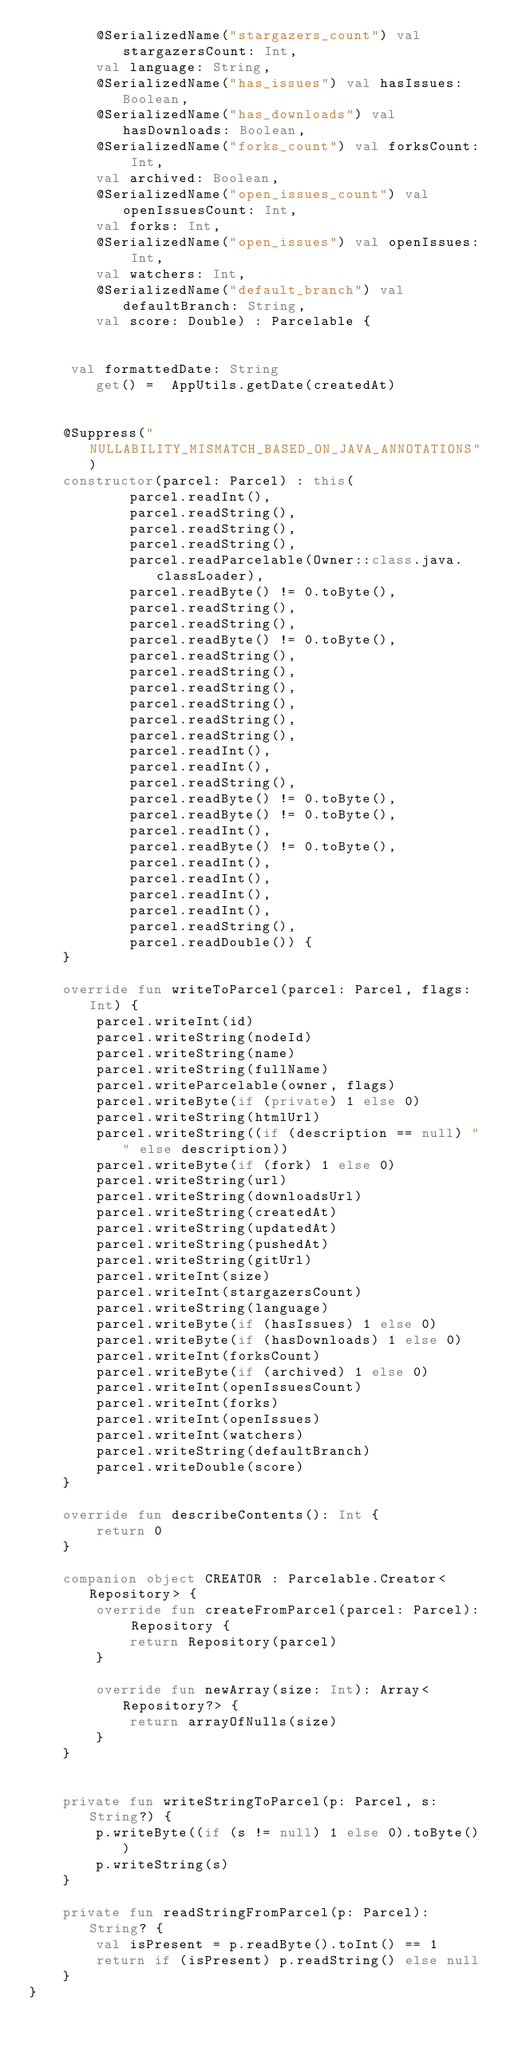<code> <loc_0><loc_0><loc_500><loc_500><_Kotlin_>        @SerializedName("stargazers_count") val stargazersCount: Int,
        val language: String,
        @SerializedName("has_issues") val hasIssues: Boolean,
        @SerializedName("has_downloads") val hasDownloads: Boolean,
        @SerializedName("forks_count") val forksCount: Int,
        val archived: Boolean,
        @SerializedName("open_issues_count") val openIssuesCount: Int,
        val forks: Int,
        @SerializedName("open_issues") val openIssues: Int,
        val watchers: Int,
        @SerializedName("default_branch") val defaultBranch: String,
        val score: Double) : Parcelable {


     val formattedDate: String
        get() =  AppUtils.getDate(createdAt)


    @Suppress("NULLABILITY_MISMATCH_BASED_ON_JAVA_ANNOTATIONS")
    constructor(parcel: Parcel) : this(
            parcel.readInt(),
            parcel.readString(),
            parcel.readString(),
            parcel.readString(),
            parcel.readParcelable(Owner::class.java.classLoader),
            parcel.readByte() != 0.toByte(),
            parcel.readString(),
            parcel.readString(),
            parcel.readByte() != 0.toByte(),
            parcel.readString(),
            parcel.readString(),
            parcel.readString(),
            parcel.readString(),
            parcel.readString(),
            parcel.readString(),
            parcel.readInt(),
            parcel.readInt(),
            parcel.readString(),
            parcel.readByte() != 0.toByte(),
            parcel.readByte() != 0.toByte(),
            parcel.readInt(),
            parcel.readByte() != 0.toByte(),
            parcel.readInt(),
            parcel.readInt(),
            parcel.readInt(),
            parcel.readInt(),
            parcel.readString(),
            parcel.readDouble()) {
    }

    override fun writeToParcel(parcel: Parcel, flags: Int) {
        parcel.writeInt(id)
        parcel.writeString(nodeId)
        parcel.writeString(name)
        parcel.writeString(fullName)
        parcel.writeParcelable(owner, flags)
        parcel.writeByte(if (private) 1 else 0)
        parcel.writeString(htmlUrl)
        parcel.writeString((if (description == null) "" else description))
        parcel.writeByte(if (fork) 1 else 0)
        parcel.writeString(url)
        parcel.writeString(downloadsUrl)
        parcel.writeString(createdAt)
        parcel.writeString(updatedAt)
        parcel.writeString(pushedAt)
        parcel.writeString(gitUrl)
        parcel.writeInt(size)
        parcel.writeInt(stargazersCount)
        parcel.writeString(language)
        parcel.writeByte(if (hasIssues) 1 else 0)
        parcel.writeByte(if (hasDownloads) 1 else 0)
        parcel.writeInt(forksCount)
        parcel.writeByte(if (archived) 1 else 0)
        parcel.writeInt(openIssuesCount)
        parcel.writeInt(forks)
        parcel.writeInt(openIssues)
        parcel.writeInt(watchers)
        parcel.writeString(defaultBranch)
        parcel.writeDouble(score)
    }

    override fun describeContents(): Int {
        return 0
    }

    companion object CREATOR : Parcelable.Creator<Repository> {
        override fun createFromParcel(parcel: Parcel): Repository {
            return Repository(parcel)
        }

        override fun newArray(size: Int): Array<Repository?> {
            return arrayOfNulls(size)
        }
    }


    private fun writeStringToParcel(p: Parcel, s: String?) {
        p.writeByte((if (s != null) 1 else 0).toByte())
        p.writeString(s)
    }

    private fun readStringFromParcel(p: Parcel): String? {
        val isPresent = p.readByte().toInt() == 1
        return if (isPresent) p.readString() else null
    }
}

</code> 